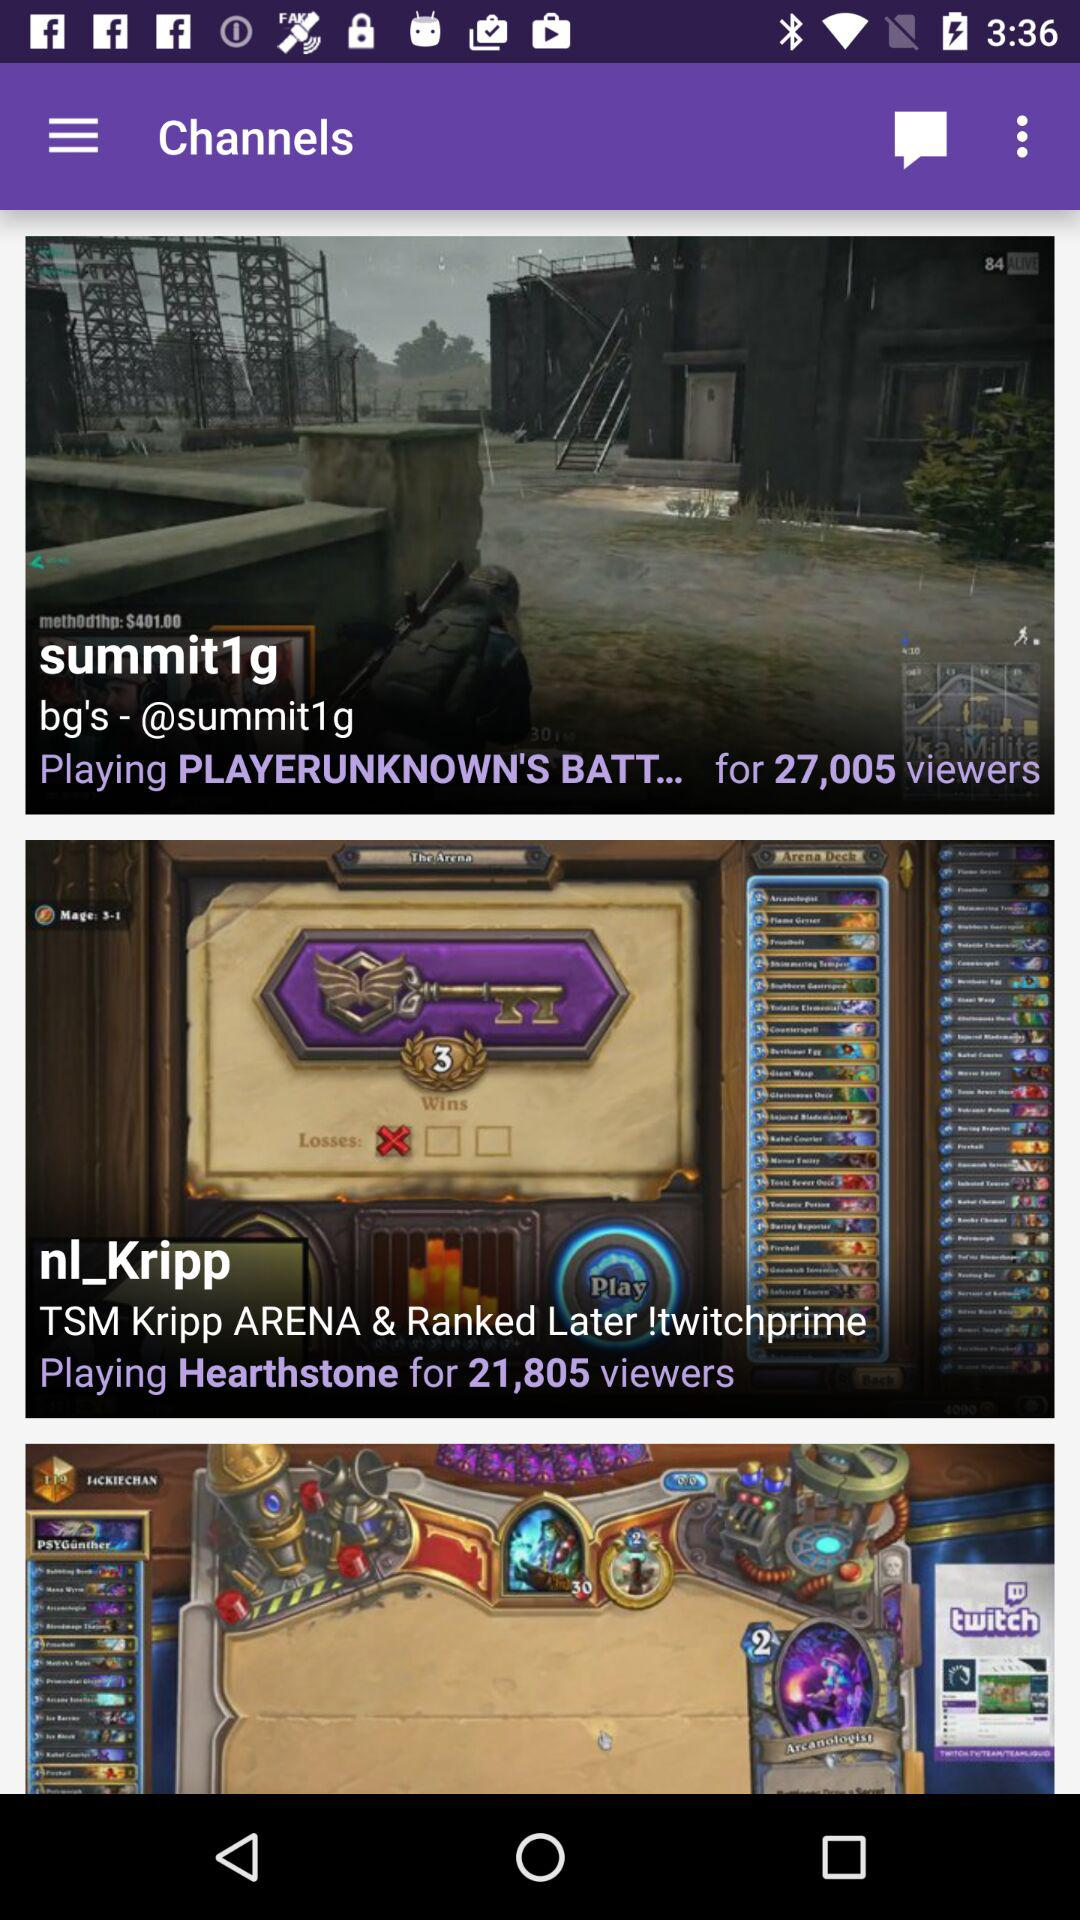What game is playing for 21,805 viewers? The game is Hearthstone. 